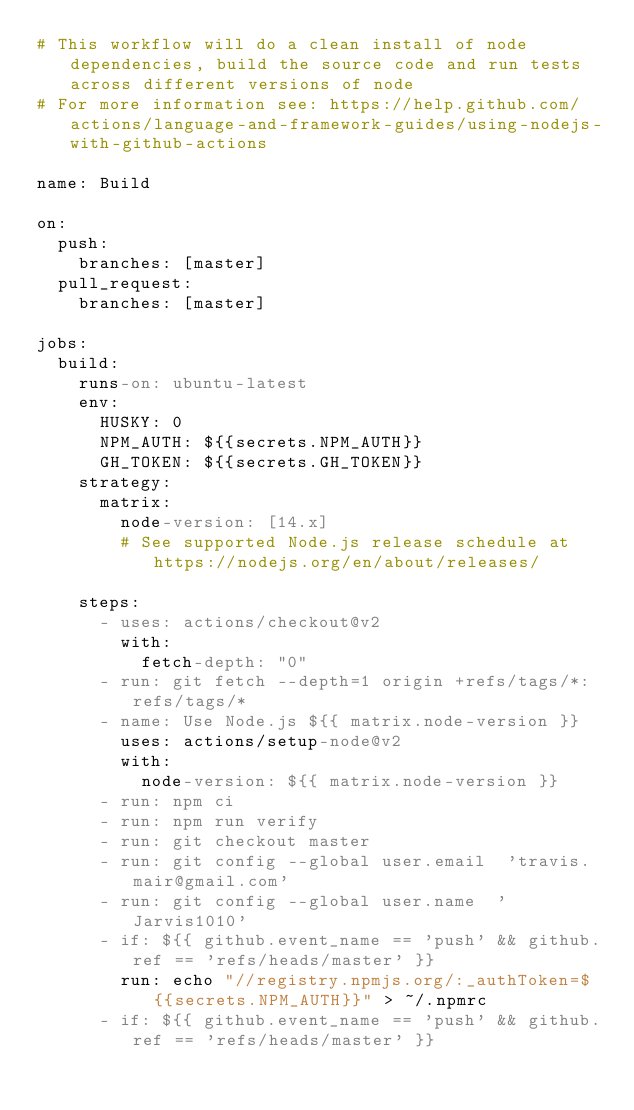<code> <loc_0><loc_0><loc_500><loc_500><_YAML_># This workflow will do a clean install of node dependencies, build the source code and run tests across different versions of node
# For more information see: https://help.github.com/actions/language-and-framework-guides/using-nodejs-with-github-actions

name: Build

on:
  push:
    branches: [master]
  pull_request:
    branches: [master]

jobs:
  build:
    runs-on: ubuntu-latest
    env:
      HUSKY: 0
      NPM_AUTH: ${{secrets.NPM_AUTH}}
      GH_TOKEN: ${{secrets.GH_TOKEN}}
    strategy:
      matrix:
        node-version: [14.x]
        # See supported Node.js release schedule at https://nodejs.org/en/about/releases/

    steps:
      - uses: actions/checkout@v2
        with:
          fetch-depth: "0"
      - run: git fetch --depth=1 origin +refs/tags/*:refs/tags/*
      - name: Use Node.js ${{ matrix.node-version }}
        uses: actions/setup-node@v2
        with:
          node-version: ${{ matrix.node-version }}
      - run: npm ci
      - run: npm run verify
      - run: git checkout master
      - run: git config --global user.email  'travis.mair@gmail.com'
      - run: git config --global user.name  'Jarvis1010'
      - if: ${{ github.event_name == 'push' && github.ref == 'refs/heads/master' }}
        run: echo "//registry.npmjs.org/:_authToken=${{secrets.NPM_AUTH}}" > ~/.npmrc
      - if: ${{ github.event_name == 'push' && github.ref == 'refs/heads/master' }}</code> 